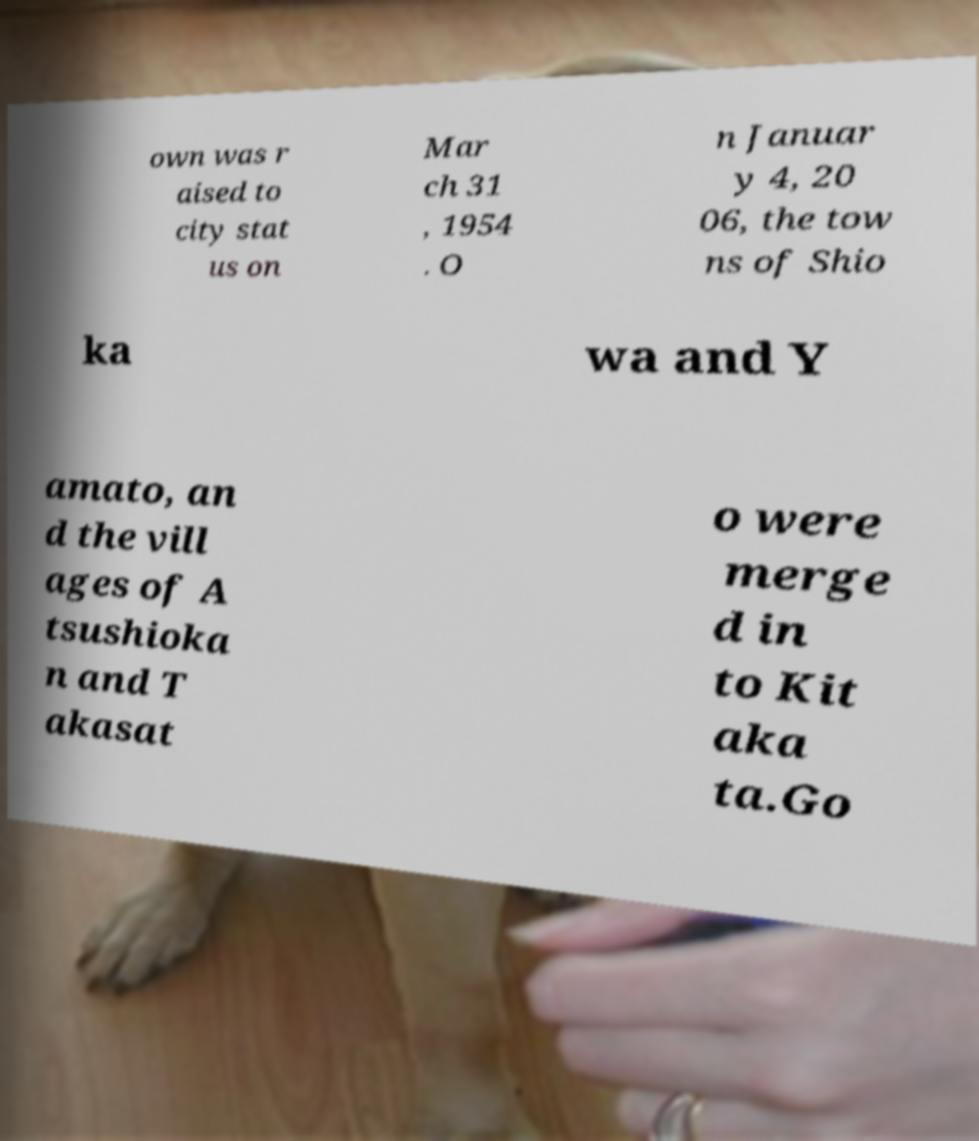Could you extract and type out the text from this image? own was r aised to city stat us on Mar ch 31 , 1954 . O n Januar y 4, 20 06, the tow ns of Shio ka wa and Y amato, an d the vill ages of A tsushioka n and T akasat o were merge d in to Kit aka ta.Go 